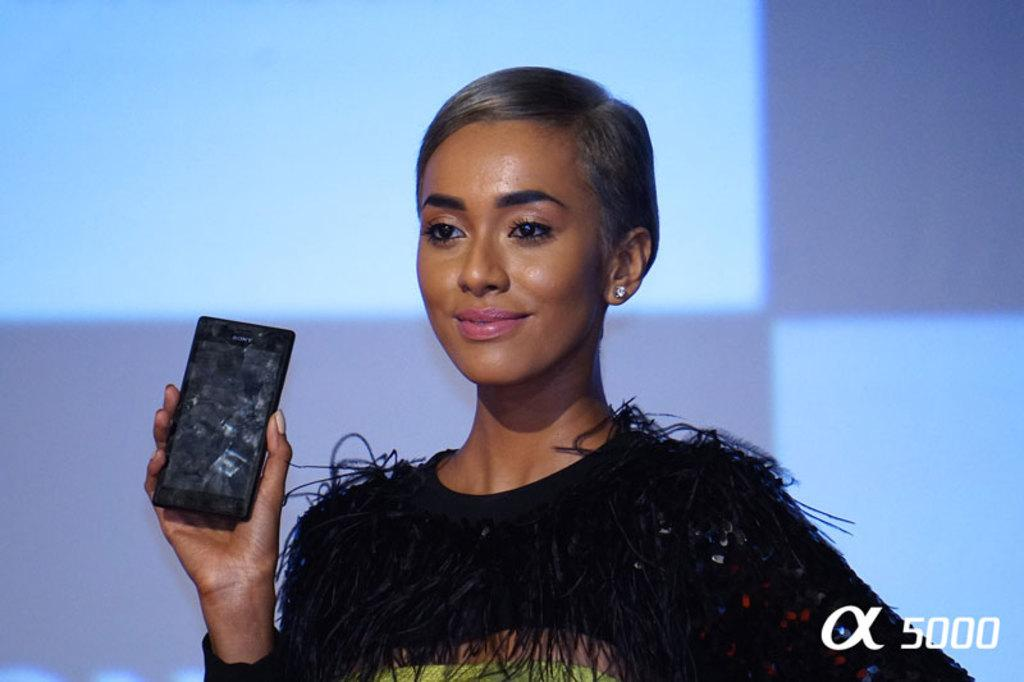Who is present in the image? There is a woman in the image. What is the woman holding in her hand? The woman is holding a phone in her hand. What type of gate is visible in the image? There is no gate present in the image; it only features a woman holding a phone. 